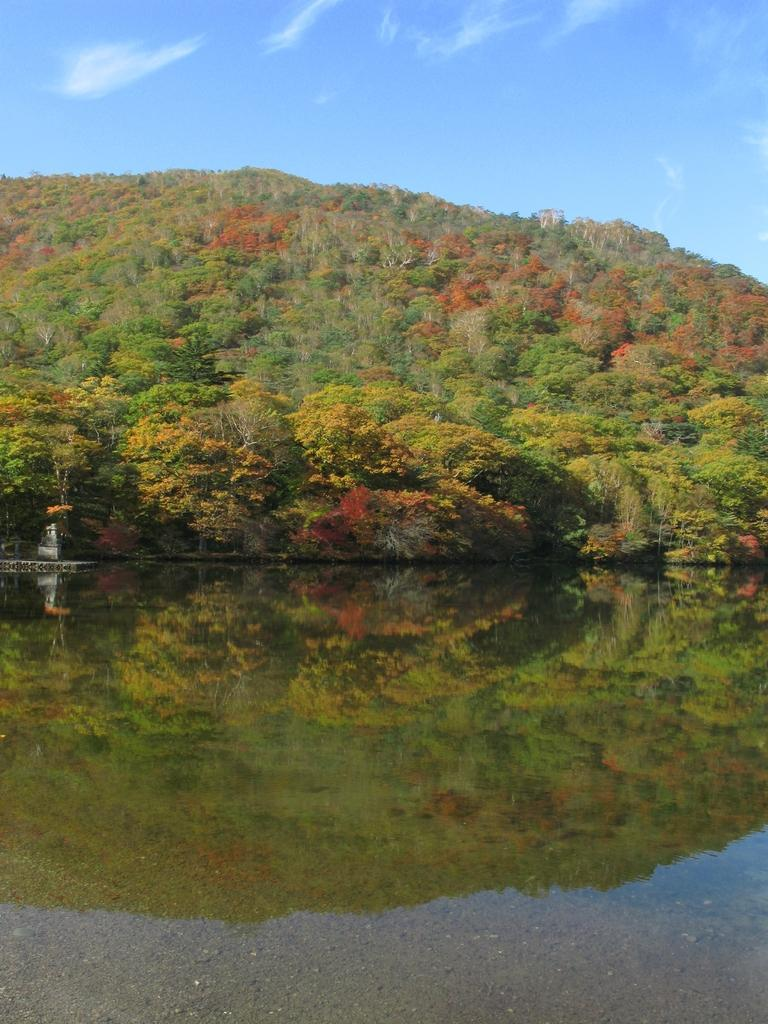What is the main object in the image? There is an object in the image, but its specific nature is not mentioned in the facts. What can be seen in the image besides the object? Water, trees, a mountain, and the sky are visible in the image. What type of natural environment is depicted in the image? The image features a mountain, trees, and water, suggesting a natural landscape. What is visible in the background of the image? The sky is visible in the background of the image. How many jewels can be seen on the object in the image? There is no mention of jewels in the image, so it is not possible to answer this question. 